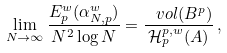Convert formula to latex. <formula><loc_0><loc_0><loc_500><loc_500>\lim _ { N \rightarrow \infty } \frac { E _ { p } ^ { w } ( \alpha _ { N , p } ^ { w } ) } { N ^ { 2 } \log N } = \frac { \ v o l ( B ^ { p } ) } { \mathcal { H } _ { p } ^ { p , w } ( A ) } \, ,</formula> 